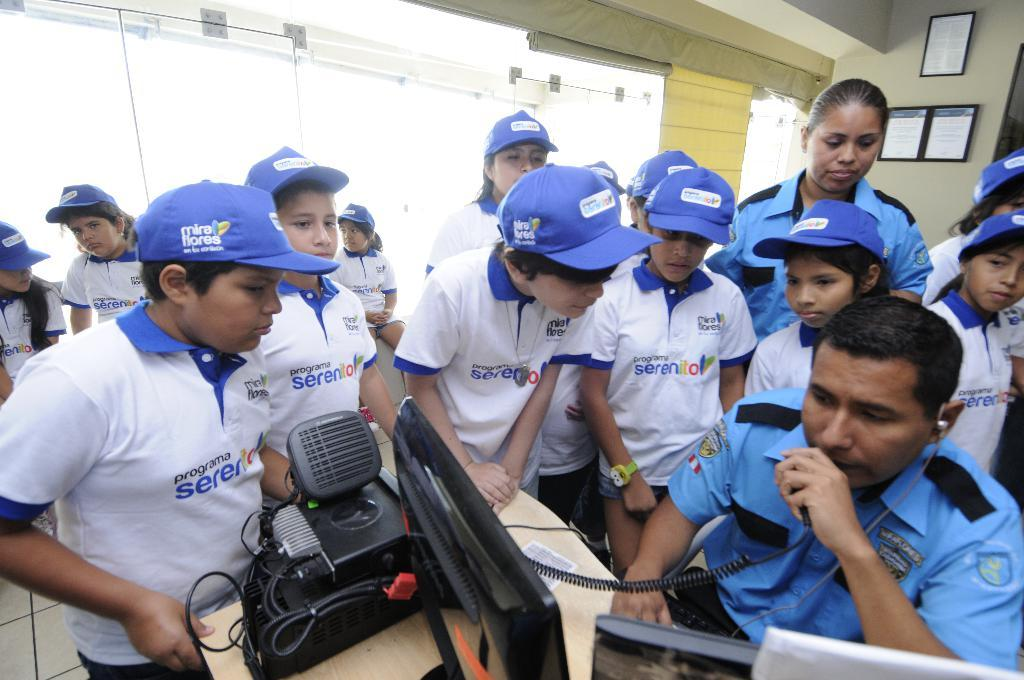Provide a one-sentence caption for the provided image. officer talking on radio while children wearing blue miraflores caps stand around him. 